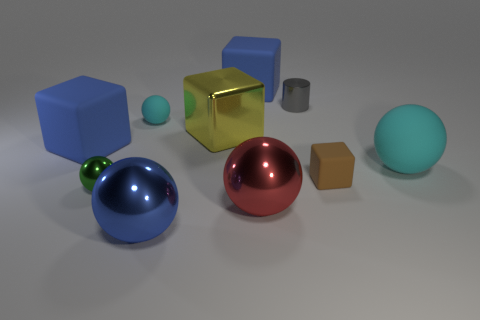Does the brown object have the same size as the blue metal thing?
Offer a terse response. No. Is there anything else of the same color as the tiny rubber block?
Offer a terse response. No. What is the shape of the blue object that is both in front of the large yellow object and behind the brown object?
Provide a succinct answer. Cube. What is the size of the object that is in front of the red ball?
Your answer should be very brief. Large. There is a large matte block behind the blue object on the left side of the green metal ball; what number of tiny rubber objects are left of it?
Ensure brevity in your answer.  1. There is a large yellow shiny block; are there any big blocks behind it?
Offer a very short reply. Yes. How many other things are there of the same size as the yellow cube?
Your response must be concise. 5. The tiny object that is both right of the large red thing and in front of the cylinder is made of what material?
Your response must be concise. Rubber. Does the blue rubber object that is to the right of the small cyan sphere have the same shape as the large blue rubber object that is in front of the yellow metal cube?
Keep it short and to the point. Yes. Is there anything else that has the same material as the gray object?
Your answer should be compact. Yes. 